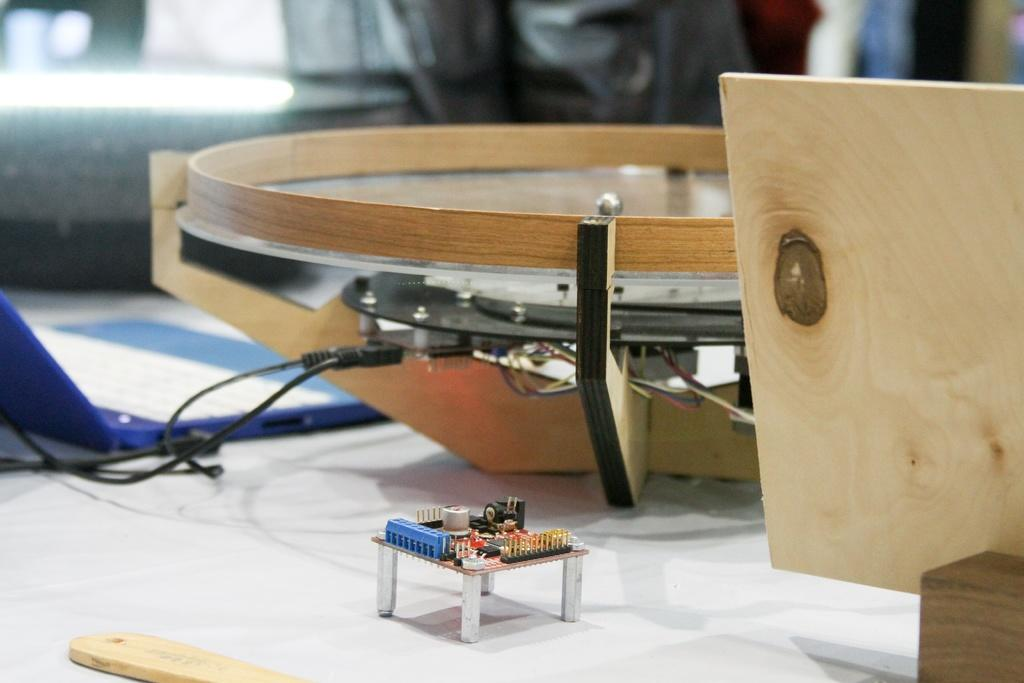What piece of furniture is present in the image? There is a table in the image. What object related to music can be seen on the table? There is a musical instrument on the table. What electronic device is also present on the table? There is a laptop on the table. Can you describe the background of the image? The background appears blurry. How many houses can be seen in the image? There are no houses visible in the image. What type of match is being played on the table? There is no match or game being played on the table; it only contains a musical instrument and a laptop. 